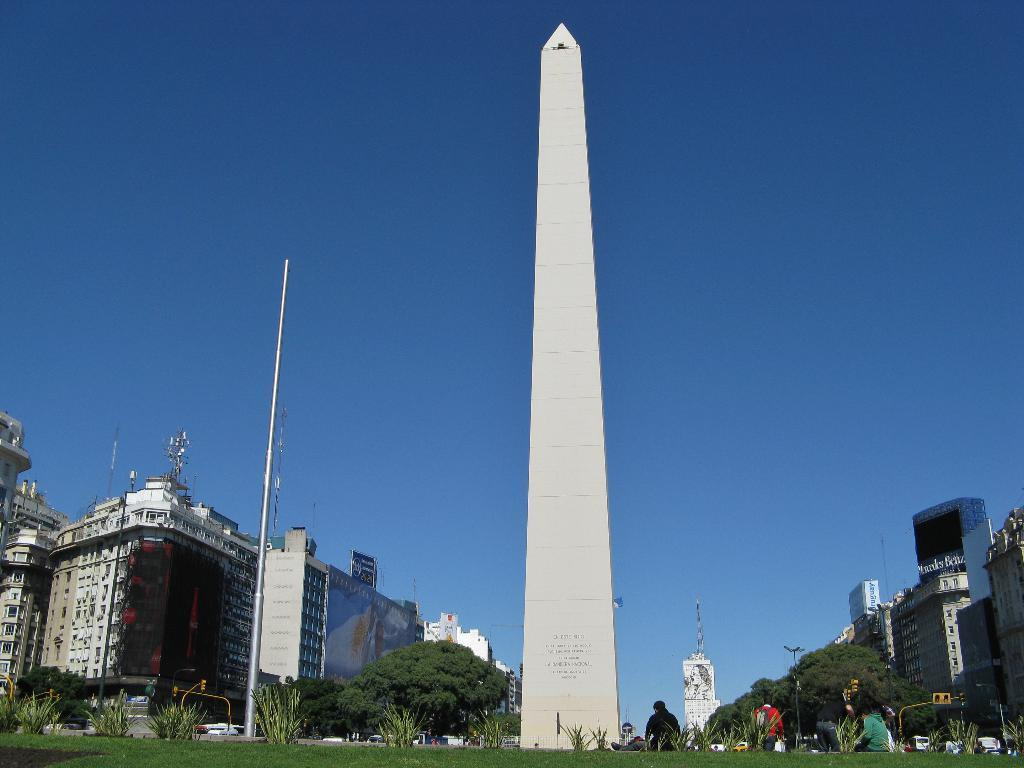What type of vegetation is present in the image? There is grass in the image. What other natural elements can be seen in the image? There are trees in the image. What man-made structures are visible in the image? There are buildings in the image. What object is standing upright in the image? There is a pole in the image. What can be seen in the background of the image? The sky is visible in the background of the image. Are there any living beings in the image? Yes, there are people in the image. What color of paste is being used by the zebra in the image? There is no zebra or paste present in the image. 